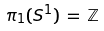<formula> <loc_0><loc_0><loc_500><loc_500>\pi _ { 1 } ( S ^ { 1 } ) \, = \, \mathbb { Z }</formula> 